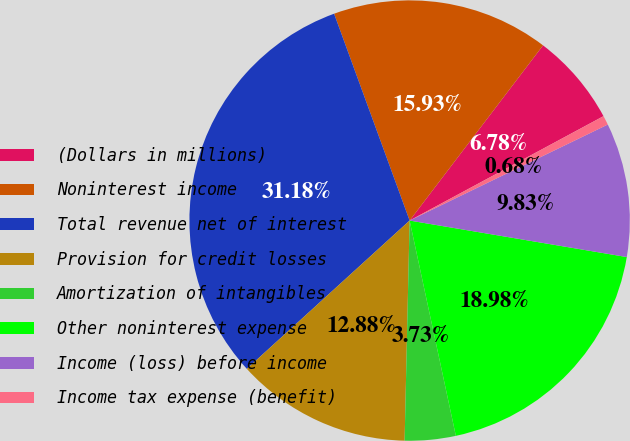Convert chart. <chart><loc_0><loc_0><loc_500><loc_500><pie_chart><fcel>(Dollars in millions)<fcel>Noninterest income<fcel>Total revenue net of interest<fcel>Provision for credit losses<fcel>Amortization of intangibles<fcel>Other noninterest expense<fcel>Income (loss) before income<fcel>Income tax expense (benefit)<nl><fcel>6.78%<fcel>15.93%<fcel>31.18%<fcel>12.88%<fcel>3.73%<fcel>18.98%<fcel>9.83%<fcel>0.68%<nl></chart> 